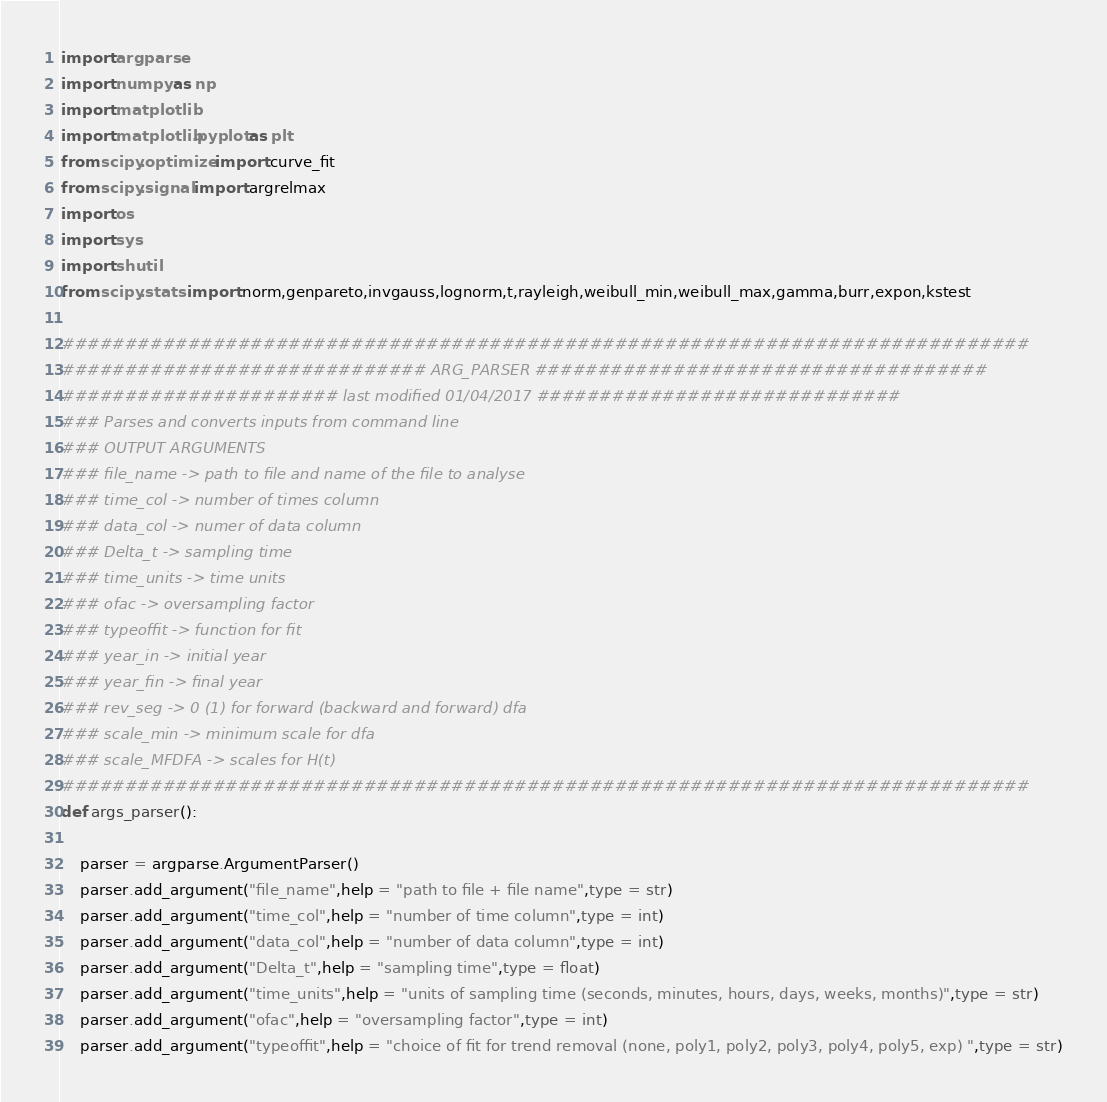Convert code to text. <code><loc_0><loc_0><loc_500><loc_500><_Python_>import argparse
import numpy as np
import matplotlib
import matplotlib.pyplot as plt
from scipy.optimize import curve_fit
from scipy.signal import argrelmax
import os
import sys
import shutil
from scipy.stats import norm,genpareto,invgauss,lognorm,t,rayleigh,weibull_min,weibull_max,gamma,burr,expon,kstest

#############################################################################
############################# ARG_PARSER ####################################
###################### last modified 01/04/2017 #############################
### Parses and converts inputs from command line
### OUTPUT ARGUMENTS
### file_name -> path to file and name of the file to analyse
### time_col -> number of times column
### data_col -> numer of data column
### Delta_t -> sampling time
### time_units -> time units
### ofac -> oversampling factor
### typeoffit -> function for fit
### year_in -> initial year
### year_fin -> final year
### rev_seg -> 0 (1) for forward (backward and forward) dfa
### scale_min -> minimum scale for dfa
### scale_MFDFA -> scales for H(t)
#############################################################################
def args_parser():

    parser = argparse.ArgumentParser()
    parser.add_argument("file_name",help = "path to file + file name",type = str)
    parser.add_argument("time_col",help = "number of time column",type = int)
    parser.add_argument("data_col",help = "number of data column",type = int)
    parser.add_argument("Delta_t",help = "sampling time",type = float)
    parser.add_argument("time_units",help = "units of sampling time (seconds, minutes, hours, days, weeks, months)",type = str)
    parser.add_argument("ofac",help = "oversampling factor",type = int)
    parser.add_argument("typeoffit",help = "choice of fit for trend removal (none, poly1, poly2, poly3, poly4, poly5, exp) ",type = str)</code> 